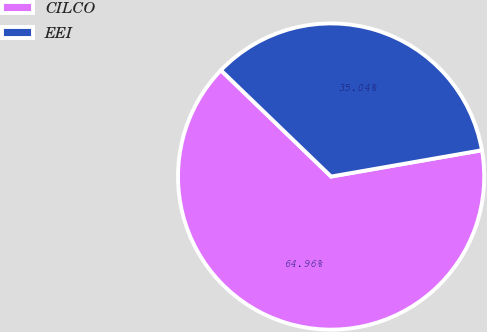<chart> <loc_0><loc_0><loc_500><loc_500><pie_chart><fcel>CILCO<fcel>EEI<nl><fcel>64.96%<fcel>35.04%<nl></chart> 